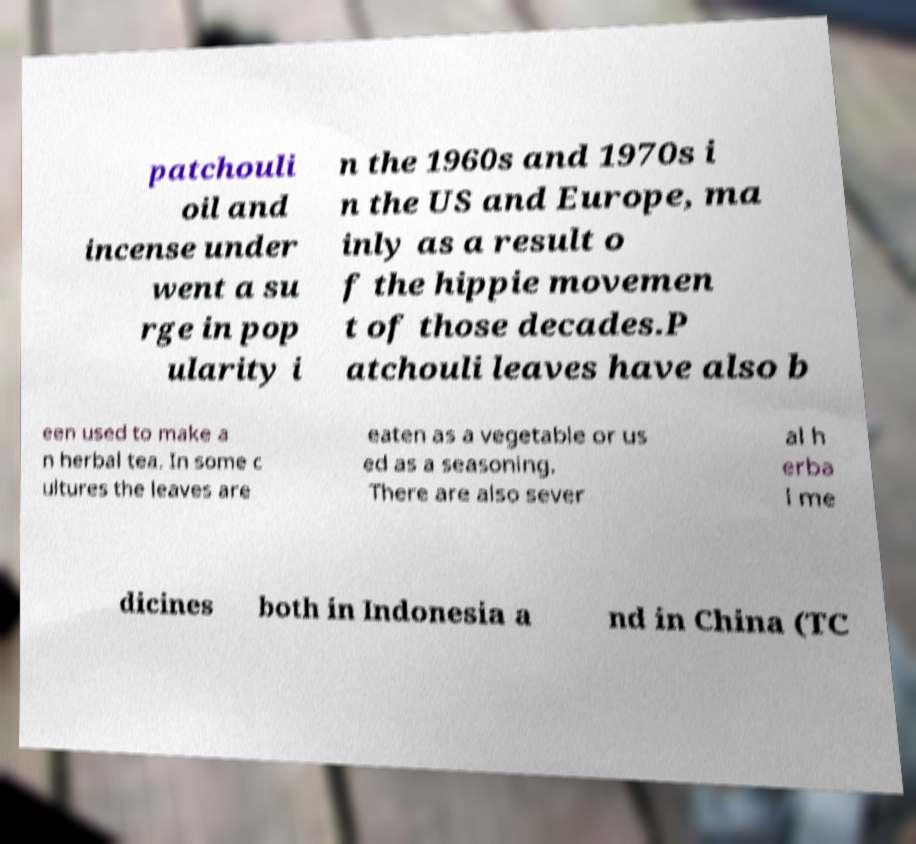What messages or text are displayed in this image? I need them in a readable, typed format. patchouli oil and incense under went a su rge in pop ularity i n the 1960s and 1970s i n the US and Europe, ma inly as a result o f the hippie movemen t of those decades.P atchouli leaves have also b een used to make a n herbal tea. In some c ultures the leaves are eaten as a vegetable or us ed as a seasoning. There are also sever al h erba l me dicines both in Indonesia a nd in China (TC 